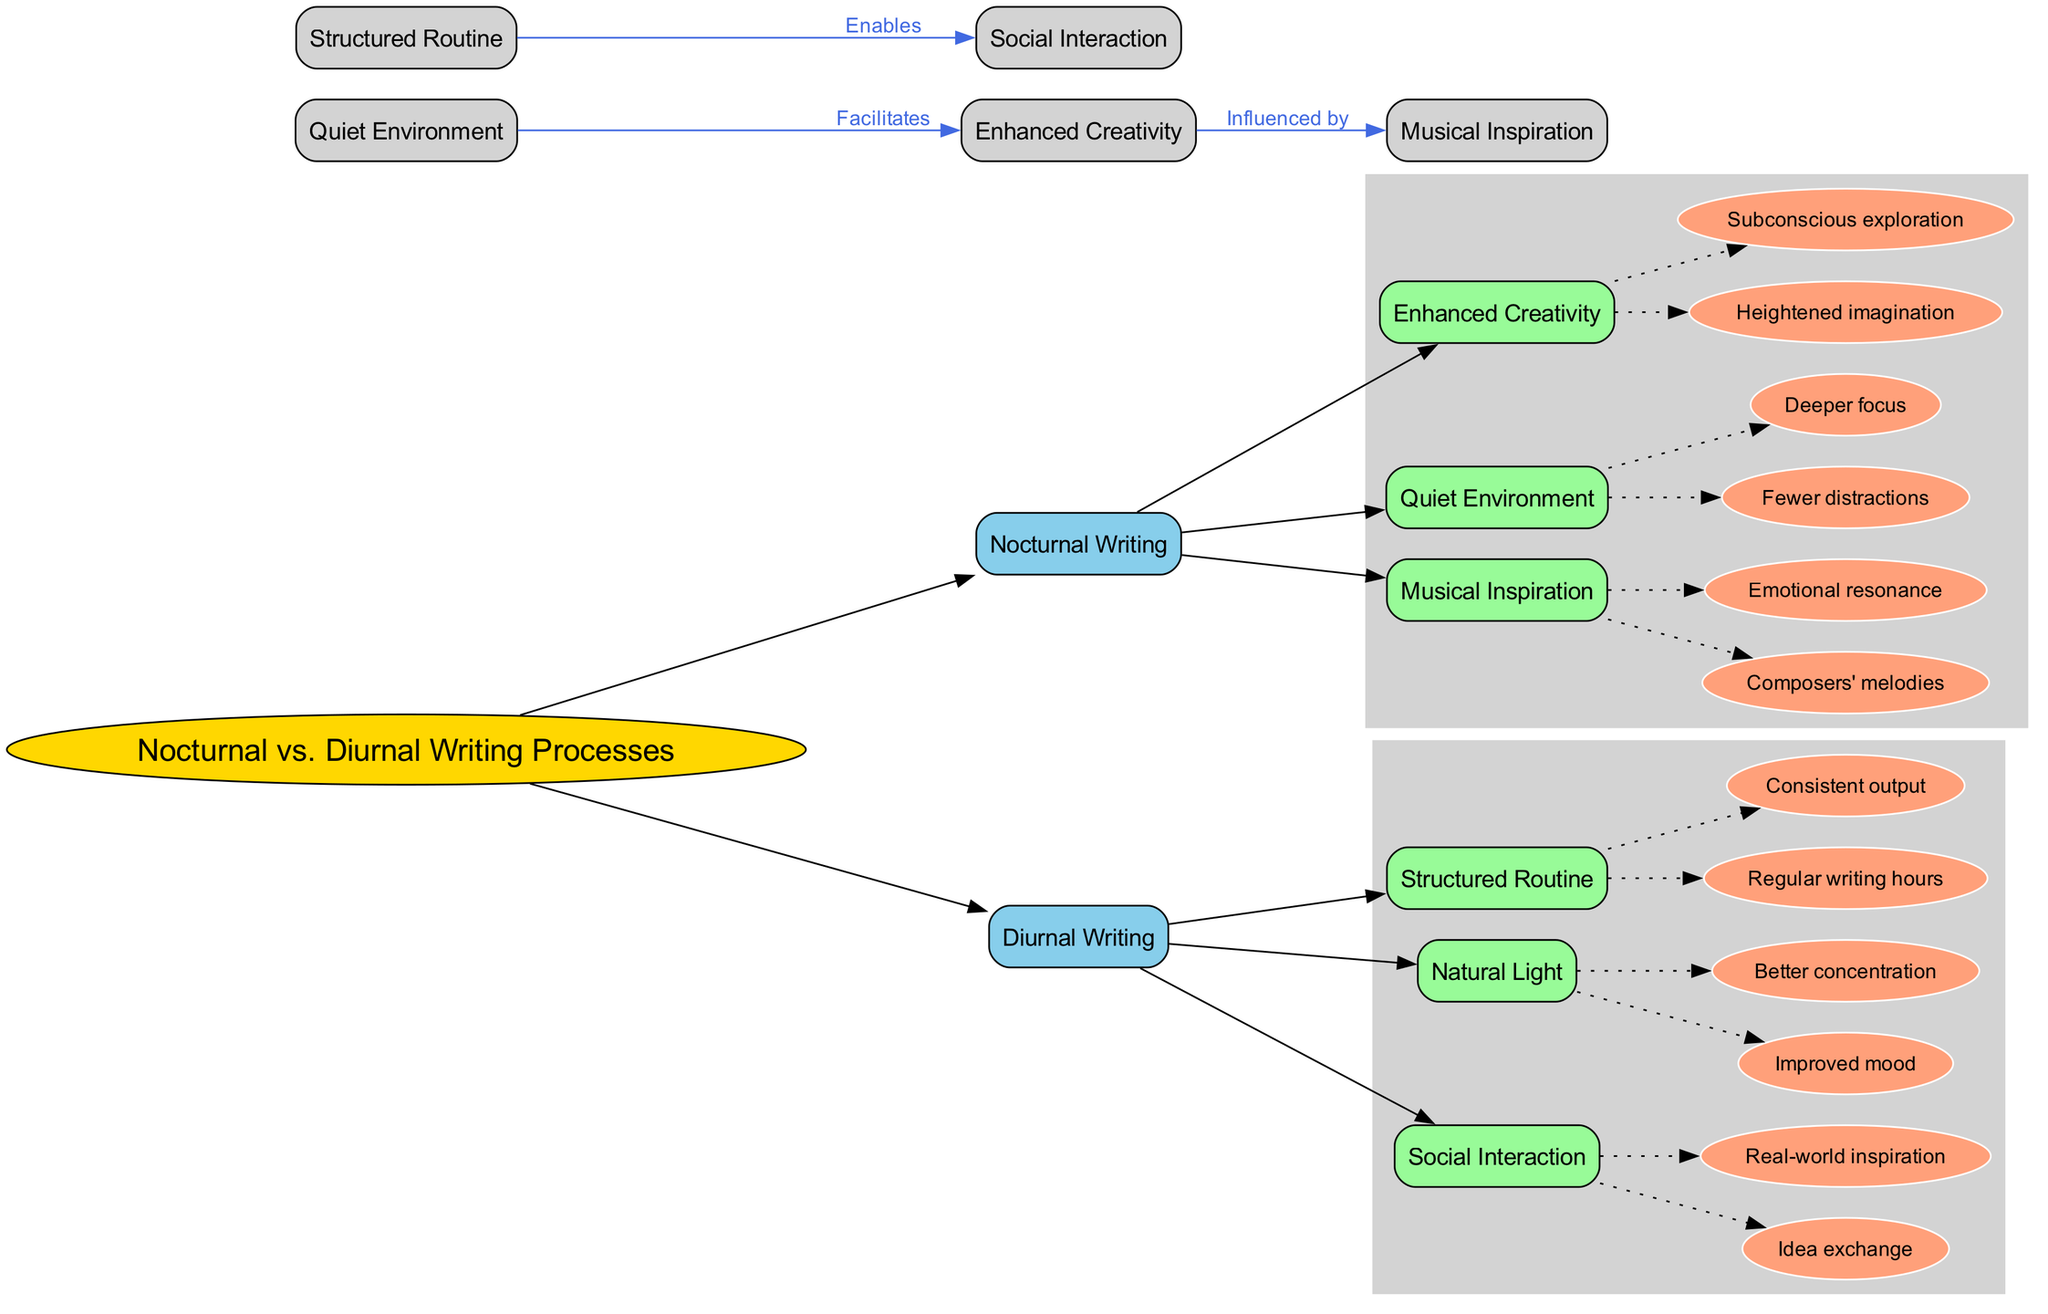What are the main categories of writing processes? The diagram shows two main categories: "Nocturnal Writing" and "Diurnal Writing". These categories are clearly indicated as branches arising from the central topic.
Answer: Nocturnal Writing, Diurnal Writing What subtopic is connected to "Enhanced Creativity"? The diagram illustrates a direct connection from "Enhanced Creativity" to "Musical Inspiration" with the label "Influenced by". This indicates that enhanced creativity is influenced by musical inspiration.
Answer: Musical Inspiration How many characteristics are associated with "Structured Routine"? The diagram lists two characteristics under "Structured Routine": "Regular writing hours" and "Consistent output". Therefore, the total number of characteristics is two.
Answer: 2 What facilitates "Enhanced Creativity"? The diagram indicates a relationship where "Quiet Environment" facilitates "Enhanced Creativity". This connection helps to understand the supporting role of a quiet space for creativity in writing.
Answer: Quiet Environment Which subtopics are listed under "Nocturnal Writing"? There are three subtopics listed under "Nocturnal Writing": "Enhanced Creativity", "Quiet Environment", and "Musical Inspiration". These are displayed as branches stemming from the nocturnal writing category.
Answer: Enhanced Creativity, Quiet Environment, Musical Inspiration What is a common feature of both "Natural Light" and "Social Interaction"? Both "Natural Light" and "Social Interaction" are characteristics listed under their respective writing processes. The common feature is that they enhance the respective writing experience, specifically for diurnal writers.
Answer: They enhance writing experience What connection enables social interaction? The diagram shows that "Structured Routine" enables "Social Interaction". This relationship suggests that a structured writing schedule can lead to more opportunities for social interaction.
Answer: Structured Routine Explain the overall influence of a quiet environment on nocturnal writing processes. The diagram illustrates that a "Quiet Environment" directly facilitates "Enhanced Creativity", suggesting that for nocturnal writers, having fewer distractions allows for deeper focus and more imaginative exploration. This creates a direct and significant impact on their creative output.
Answer: Facilitates Enhanced Creativity What two elements are characteristics of "Musical Inspiration"? The diagram lists "Composers' melodies" and "Emotional resonance" as the two characteristics of "Musical Inspiration". These elements indicate the emotional and artistic influences that music has on a writer's creative process during nocturnal writing.
Answer: Composers' melodies, Emotional resonance 